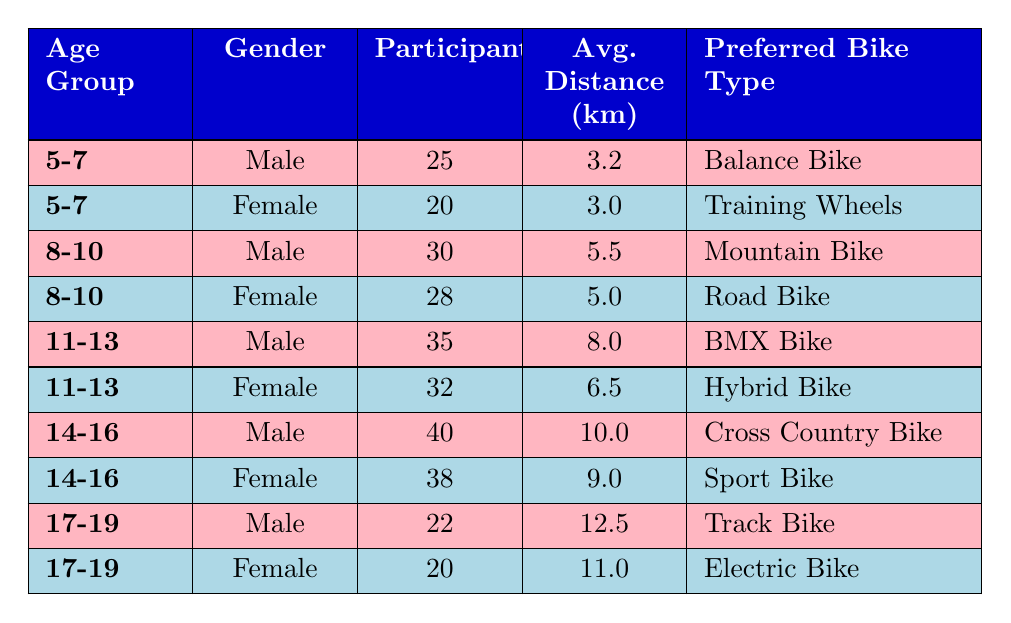What age group has the highest number of male participants? By reviewing the table, we can see that the "14-16" age group has the highest number of male participants, which is 40.
Answer: 14-16 What is the average distance cycled by female participants aged 11-13? The average distance for female participants aged 11-13 is given as 6.5 km.
Answer: 6.5 km Is the preferred bike type for male participants in the age group 8-10 a Mountain Bike? Yes, according to the table, the preferred bike type for male participants aged 8-10 is indeed a Mountain Bike.
Answer: Yes What is the total number of participants across all age groups for females? Summing the participants for all female age groups: 20 (5-7) + 28 (8-10) + 32 (11-13) + 38 (14-16) + 20 (17-19) = 138.
Answer: 138 How does the average distance for male participants aged 14-16 compare to that of male participants aged 5-7? The average distance for male participants aged 14-16 is 10.0 km while for those aged 5-7 it's 3.2 km. The difference is 10.0 - 3.2 = 6.8 km, indicating that 14-16 year olds cycle significantly further on average.
Answer: 6.8 km Which age group shows the least number of participants for females? Reviewing the table, the age group that shows the least number of female participants is 17-19, with 20 participants.
Answer: 17-19 What is the preferred bike type for male participants aged 17-19? According to the table, the preferred bike type for male participants aged 17-19 is a Track Bike.
Answer: Track Bike How many more male participants are there in the 11-13 age group compared to the 5-7 age group? The number of male participants in the 11-13 age group is 35 and in the 5-7 age group is 25. The difference is 35 - 25 = 10 more male participants in the 11-13 group.
Answer: 10 What is the average distance cycled by all participants across the age groups? The average distances are as follows: 3.2 (5-7) + 3.0 (5-7) + 5.5 (8-10) + 5.0 (8-10) + 8.0 (11-13) + 6.5 (11-13) + 10.0 (14-16) + 9.0 (14-16) + 12.5 (17-19) + 11.0 (17-19) = 58.7 km for 10 participants; average = 58.7 / 10 = 5.87 km.
Answer: 5.87 km 